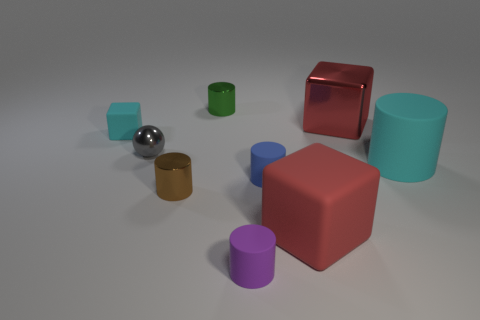Subtract all purple cylinders. How many cylinders are left? 4 Subtract 1 cylinders. How many cylinders are left? 4 Subtract all gray cylinders. Subtract all red blocks. How many cylinders are left? 5 Add 1 big cyan cylinders. How many objects exist? 10 Subtract all blocks. How many objects are left? 6 Subtract 0 yellow spheres. How many objects are left? 9 Subtract all tiny green shiny blocks. Subtract all purple objects. How many objects are left? 8 Add 4 tiny gray balls. How many tiny gray balls are left? 5 Add 3 small cyan things. How many small cyan things exist? 4 